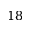<formula> <loc_0><loc_0><loc_500><loc_500>1 8</formula> 